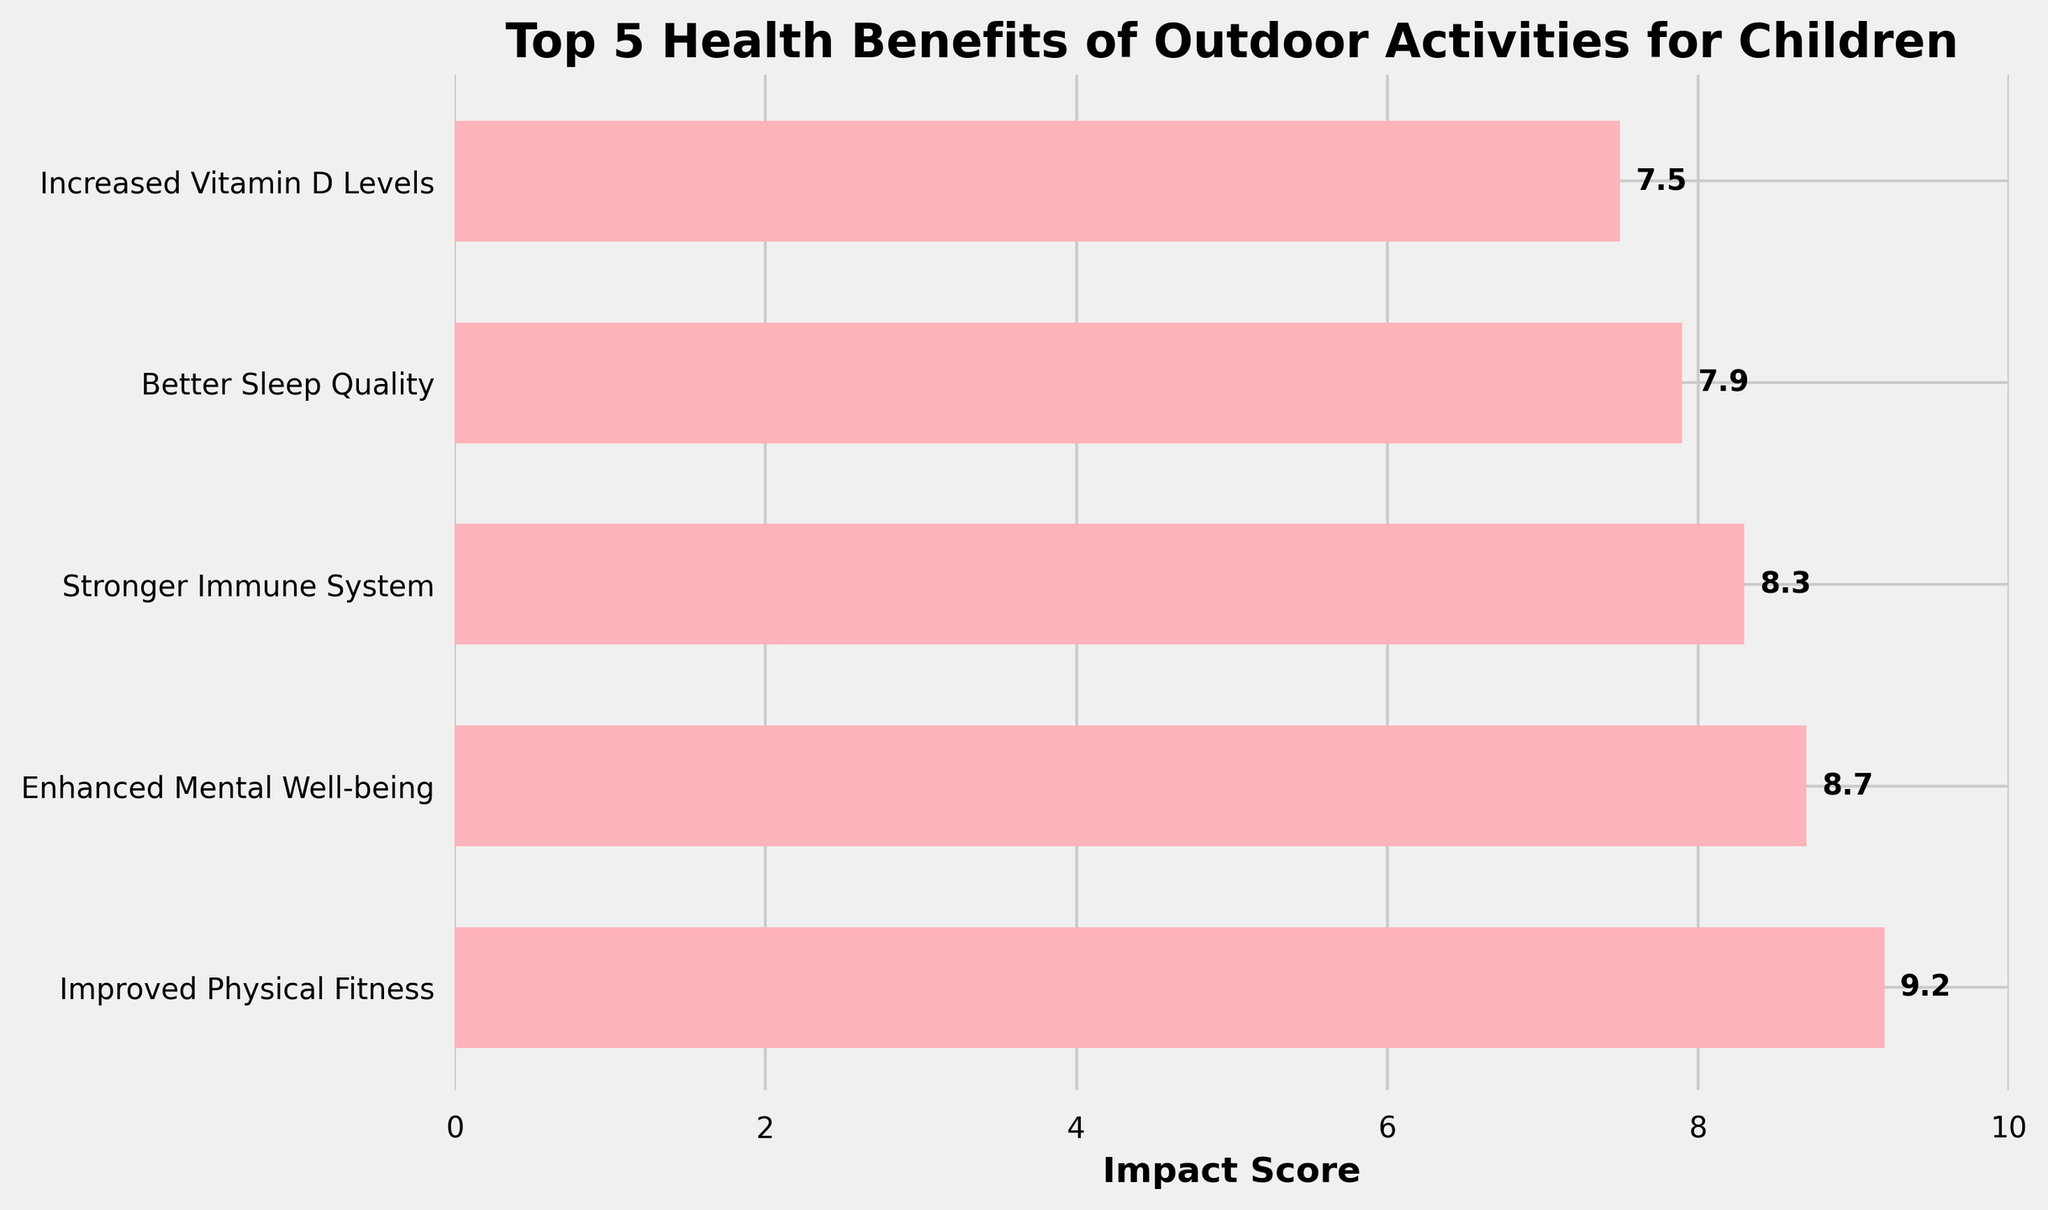Which health benefit has the highest impact score? The bar chart shows different health benefits with corresponding impact scores. "Improved Physical Fitness" is at the top with a score of 9.2.
Answer: Improved Physical Fitness Which health benefit has the lowest impact score? The figure ranks the health benefits from highest to lowest score. "Increased Vitamin D Levels" is listed at the bottom with a score of 7.5.
Answer: Increased Vitamin D Levels What is the difference in impact score between "Improved Physical Fitness" and "Better Sleep Quality"? Subtract the impact score of "Better Sleep Quality" (7.9) from that of "Improved Physical Fitness" (9.2): 9.2 - 7.9 = 1.3.
Answer: 1.3 Is the impact score of "Enhanced Mental Well-being" higher than "Stronger Immune System"? By comparing their impact scores, "Enhanced Mental Well-being" has a score of 8.7, which is higher than "Stronger Immune System" with a score of 8.3.
Answer: Yes If we average the impact scores of "Improved Physical Fitness" and "Increased Vitamin D Levels", what is the result? Calculate the average by adding the scores of both benefits (9.2 + 7.5) and then dividing by 2: (9.2 + 7.5) / 2 = 8.35.
Answer: 8.35 Which two health benefits are closest in their impact scores? "Enhanced Mental Well-being" (8.7) and "Stronger Immune System" (8.3) have the closest impact scores with a small difference of 0.4.
Answer: Enhanced Mental Well-being and Stronger Immune System Are all impact scores above 7? By examining the impact scores of all benefits (9.2, 8.7, 8.3, 7.9, 7.5), it is clear that each value is greater than 7.
Answer: Yes What is the combined impact score of "Improved Physical Fitness", "Enhanced Mental Well-being", and "Stronger Immune System"? Add the impact scores of all three benefits: 9.2 + 8.7 + 8.3 = 26.2.
Answer: 26.2 